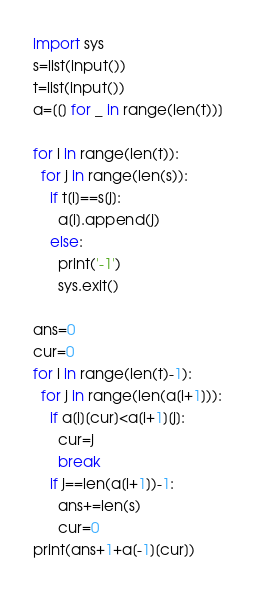Convert code to text. <code><loc_0><loc_0><loc_500><loc_500><_Python_>import sys
s=list(input())
t=list(input())
a=[[] for _ in range(len(t))]

for i in range(len(t)):
  for j in range(len(s)):
    if t[i]==s[j]:
      a[i].append(j)
    else:
      print('-1')
      sys.exit()

ans=0
cur=0
for i in range(len(t)-1):
  for j in range(len(a[i+1])):
    if a[i][cur]<a[i+1][j]:
      cur=j
      break
    if j==len(a[i+1])-1:
      ans+=len(s)
      cur=0
print(ans+1+a[-1][cur])</code> 